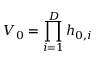<formula> <loc_0><loc_0><loc_500><loc_500>V _ { 0 } = \prod _ { i = 1 } ^ { D } h _ { 0 , i }</formula> 